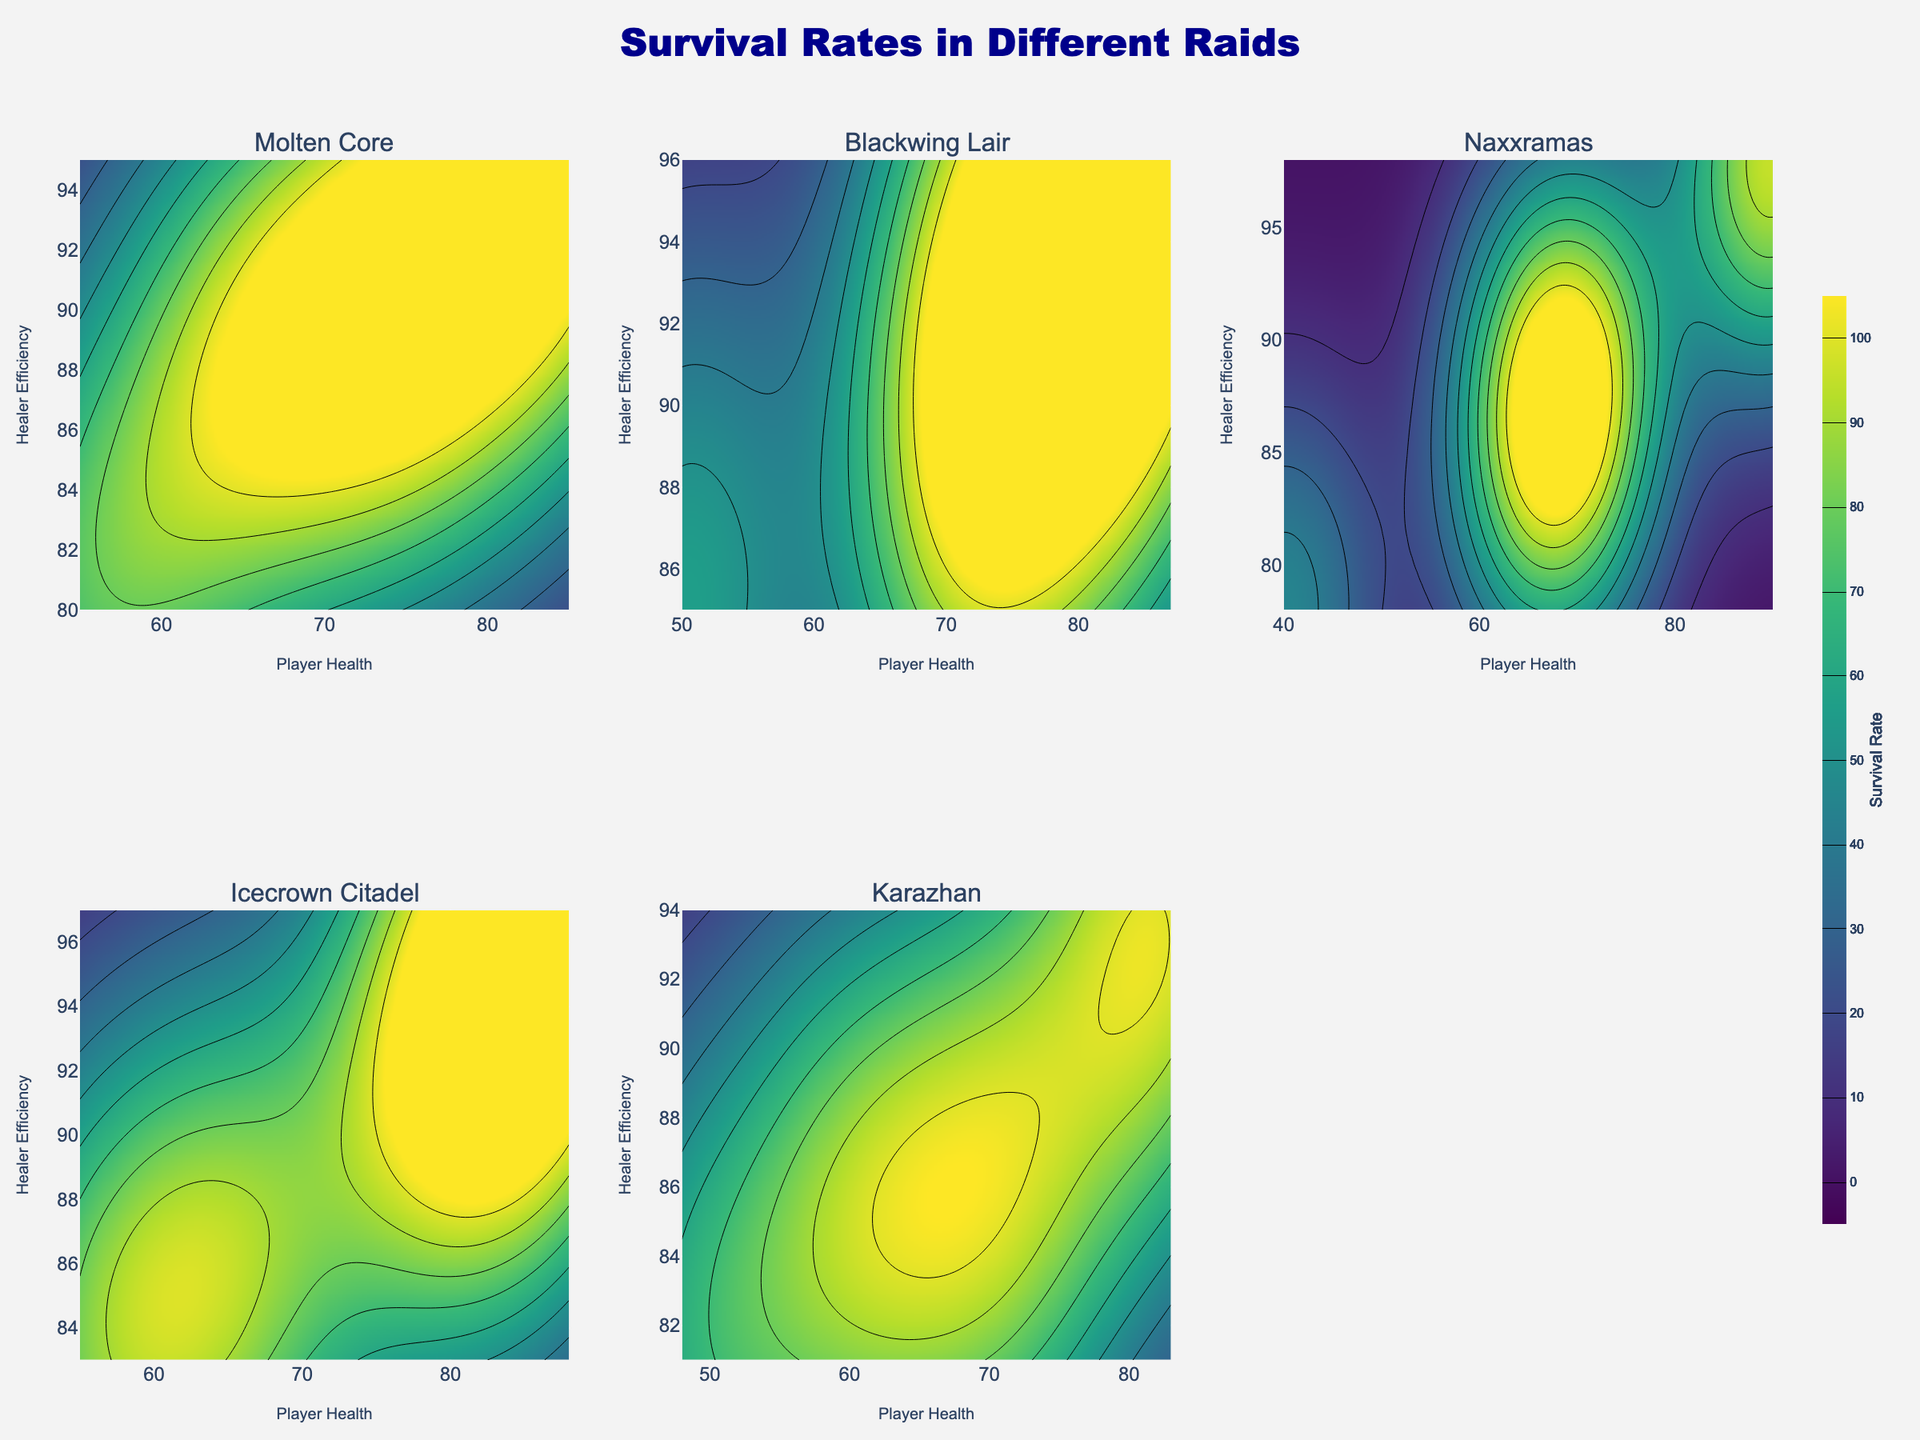What's the title of the figure? The title of the figure is written at the top center in large font.
Answer: Survival Rates in Different Raids What are the x and y-axis labels of the contour plots? You can see the labels of the x and y axes that appear on each subplot; "Player Health" is on the x-axis and "Healer Efficiency" is on the y-axis.
Answer: Player Health, Healer Efficiency Which raid has the highest survival rate when both Player Health and Healer Efficiency are maximized? By closely examining each subplot, the colors indicating the highest survival rates are visible when both features are maximized, particularly in the Naxxramas and Icecrown Citadel subplots.
Answer: Naxxramas Between Molten Core and Blackwing Lair, which has better survival rates? Compare the overall color brightness and gradient of the contour plots for Molten Core and Blackwing Lair. Molten Core has lighter (more yellow-greenish) regions indicating better survival rates.
Answer: Molten Core In which raid does intermediate Player Health (around 65-75) combined with high Healer Efficiency (above 90) result in a survival rate above 80? Looking into the specific region of each subplot, check where Player Health is around 65-75 and Healer Efficiency is above 90. The lighter-colored regions in Blackwing Lair and Naxxramas show higher survival rates.
Answer: Blackwing Lair, Naxxramas What's the difference in survival rate between the raid with the lowest and highest values? The lowest survivial rate can be observed where contour levels are the darkest, and the highest is where it is the brightest green. Subtract the two values found in the darkest (Naxxramas ~45) and brightest (~95) regions.
Answer: 50 Which raid is most heavily influenced by Healer Efficiency in terms of survival rates? Check subplots for noticeable differences in survival rate contours as Healer Efficiency changes. Notice that in Icecrown Citadel and Naxxramas, changes in Healer Efficiency visibly impact survival rates more.
Answer: Naxxramas How do survival rates in Karazhan compare to Molten Core for similar Player Health and Healer Efficiency? Compare regions with similar coordinates in both subplots. Notice Molten Core contours are generally higher (lighter indicating higher survival) than Karazhan for equivalent points.
Answer: Molten Core Which raid shows a drastic drop in survival rates when Player Health is low and Healer Efficiency is below average? Observe the portion of subplots where both x and y are low. Naxxramas and Karazhan show a steep decline in these regions.
Answer: Naxxramas, Karazhan 